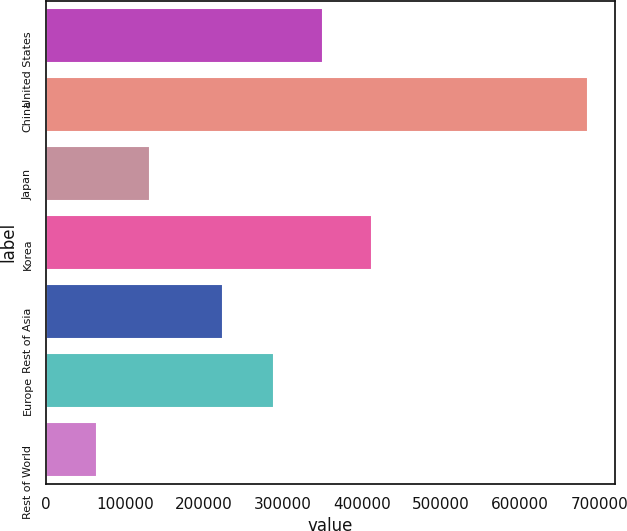Convert chart. <chart><loc_0><loc_0><loc_500><loc_500><bar_chart><fcel>United States<fcel>China<fcel>Japan<fcel>Korea<fcel>Rest of Asia<fcel>Europe<fcel>Rest of World<nl><fcel>350840<fcel>685908<fcel>131513<fcel>413006<fcel>223786<fcel>288675<fcel>64254<nl></chart> 